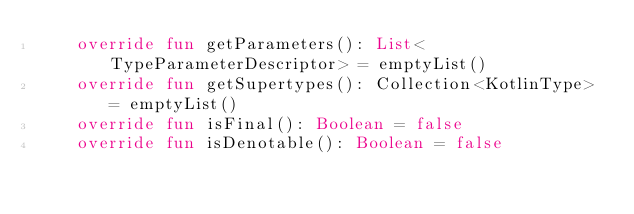Convert code to text. <code><loc_0><loc_0><loc_500><loc_500><_Kotlin_>    override fun getParameters(): List<TypeParameterDescriptor> = emptyList()
    override fun getSupertypes(): Collection<KotlinType> = emptyList()
    override fun isFinal(): Boolean = false
    override fun isDenotable(): Boolean = false</code> 